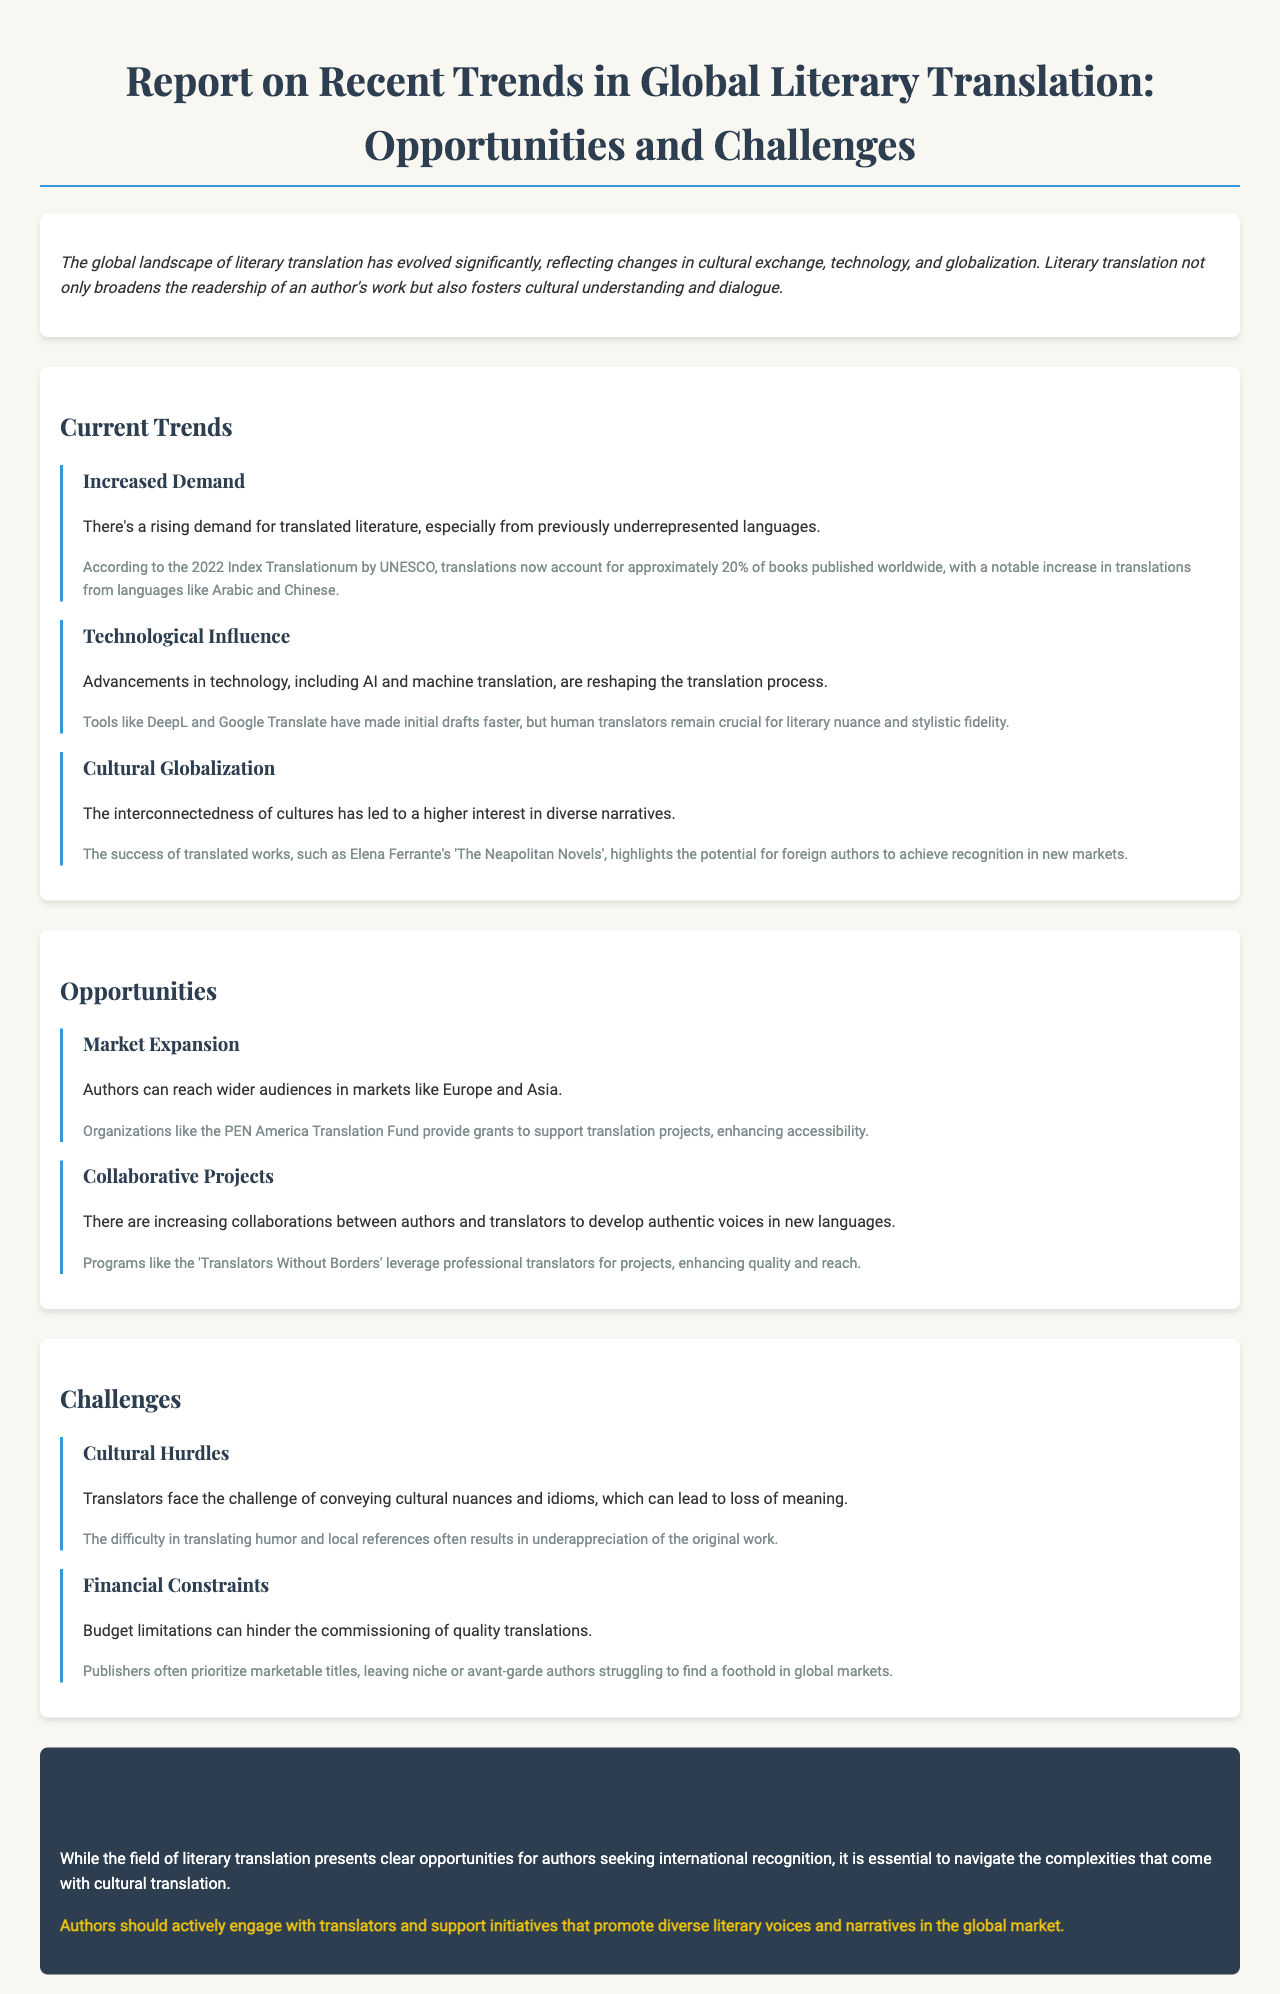What percentage of books published worldwide are translations? According to the document, translations account for approximately 20% of books published worldwide.
Answer: 20% What notable languages have seen an increase in translated literature? The document mentions a notable increase in translations from languages like Arabic and Chinese.
Answer: Arabic and Chinese What is one technological advancement influencing literary translation? The report discusses advancements in tools like DeepL and Google Translate that are reshaping the translation process.
Answer: DeepL What organization provides grants to support translation projects? The document specifies organizations like the PEN America Translation Fund as a resource for supporting translation projects.
Answer: PEN America Translation Fund What challenge do translators face in ensuring cultural nuances are conveyed? The report states that cultural hurdles cause challenges in conveying cultural nuances and idioms, which can lead to loss of meaning.
Answer: Cultural hurdles What is a primary reason publishers prioritize marketable titles? The issue outlined in the document indicates that budget limitations can hinder the commissioning of quality translations.
Answer: Budget limitations Name one program that leverages professional translators for projects. The document mentions 'Translators Without Borders' as a program that enhances quality and reach through professional translators.
Answer: Translators Without Borders What is the main conclusion regarding literary translation opportunities? The conclusion emphasizes that while there are opportunities for international recognition, complexities in cultural translation must be navigated.
Answer: Complexities in cultural translation 